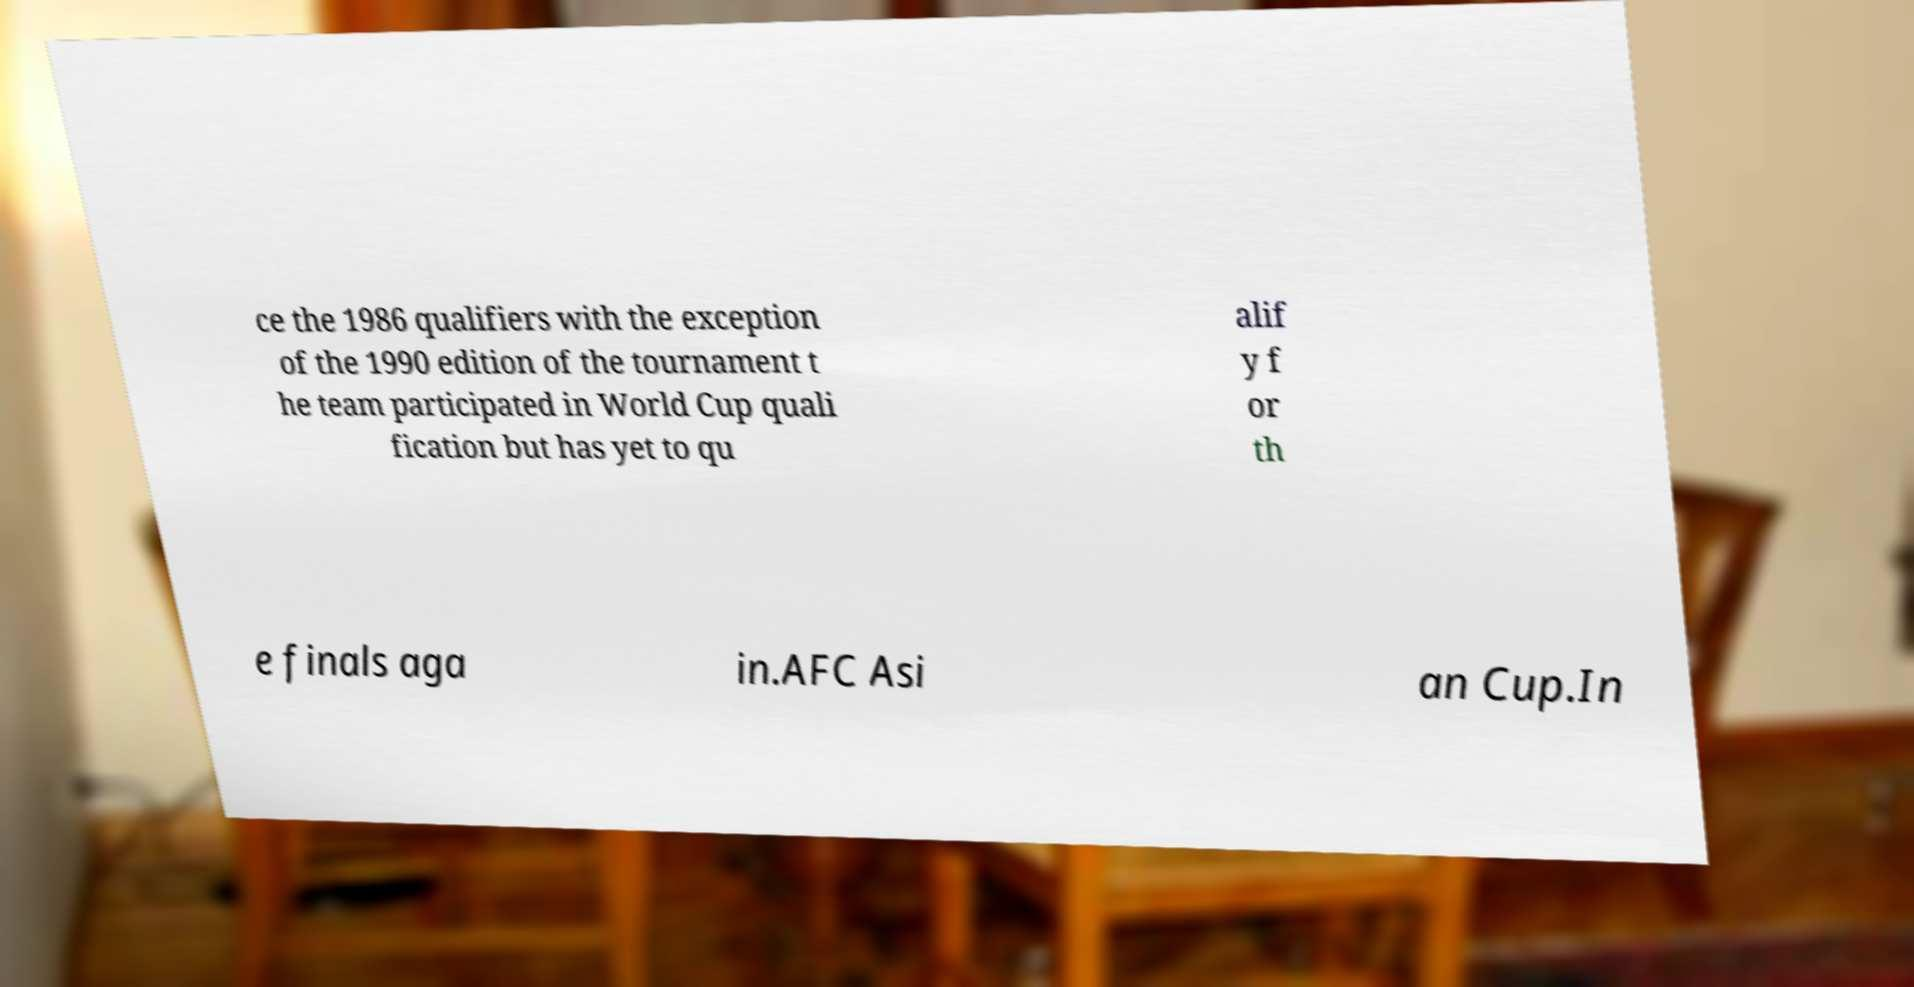Please identify and transcribe the text found in this image. ce the 1986 qualifiers with the exception of the 1990 edition of the tournament t he team participated in World Cup quali fication but has yet to qu alif y f or th e finals aga in.AFC Asi an Cup.In 